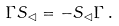Convert formula to latex. <formula><loc_0><loc_0><loc_500><loc_500>\Gamma S _ { \lhd } = - S _ { \lhd } \Gamma \, .</formula> 